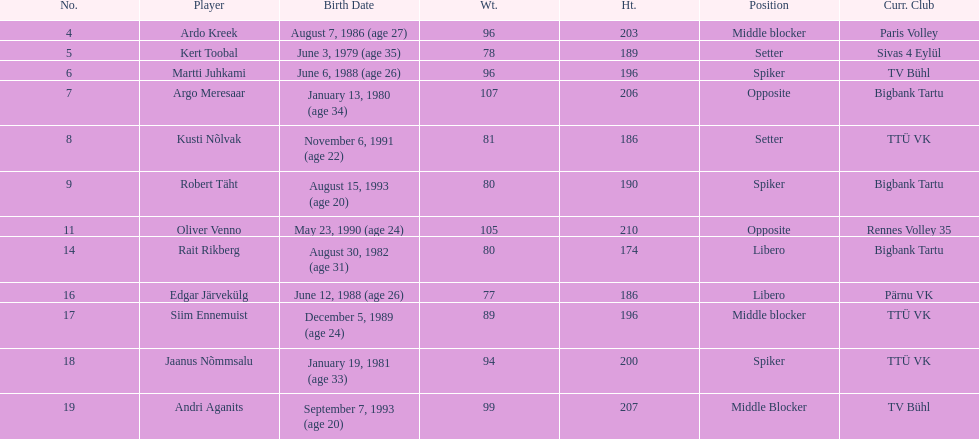Which players played the same position as ardo kreek? Siim Ennemuist, Andri Aganits. 